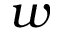<formula> <loc_0><loc_0><loc_500><loc_500>w</formula> 